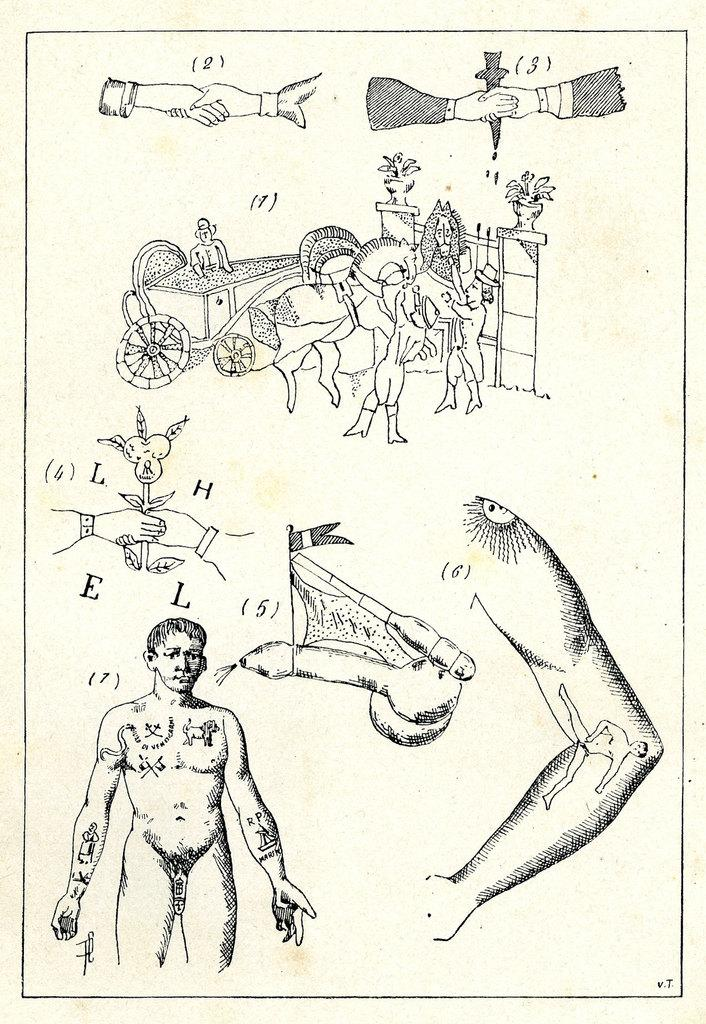What is the main subject of the paper in the image? The paper in the image contains sketches of persons, horses, and a plant. What types of living organisms are depicted in the sketches? Persons and horses are depicted in the sketches. What non-living object is also sketched on the paper? There is a sketch of a plant on the paper. What additional elements are present around the sketches on the paper? Numbers and alphabets are present around the sketches on the paper. What type of cobweb can be seen in the image? There is no cobweb present in the image; it features a paper with sketches and additional elements. How many drains are visible in the image? There are no drains visible in the image; it features a paper with sketches and additional elements. 